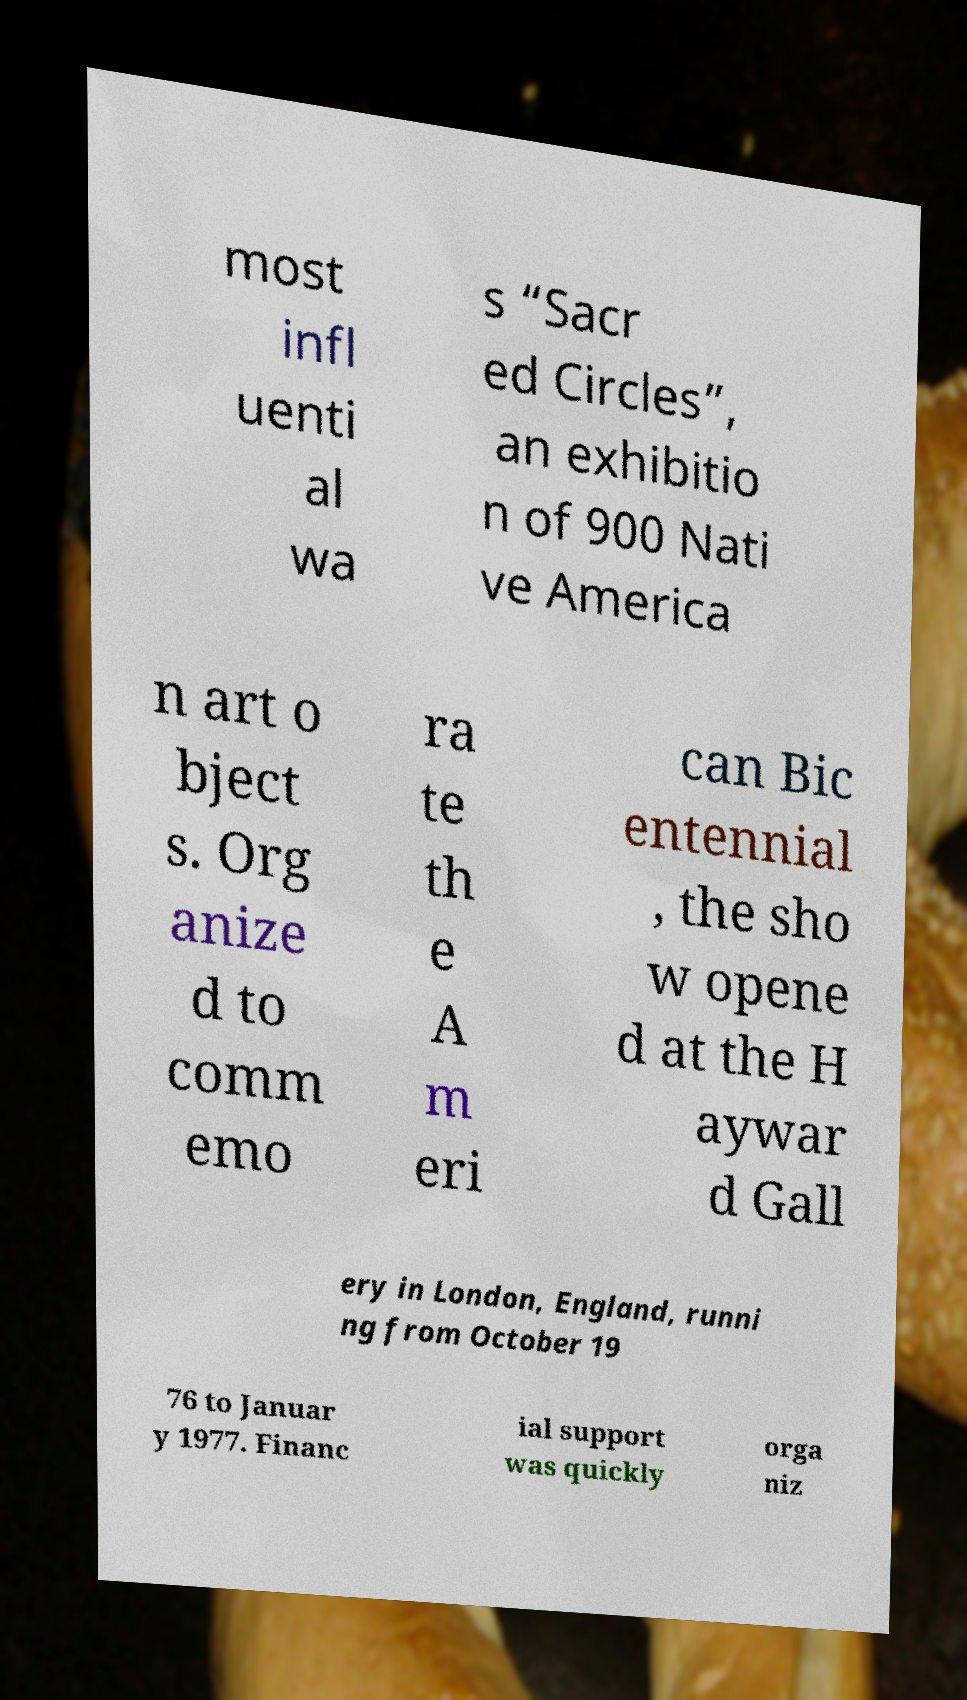Could you extract and type out the text from this image? most infl uenti al wa s “Sacr ed Circles”, an exhibitio n of 900 Nati ve America n art o bject s. Org anize d to comm emo ra te th e A m eri can Bic entennial , the sho w opene d at the H aywar d Gall ery in London, England, runni ng from October 19 76 to Januar y 1977. Financ ial support was quickly orga niz 